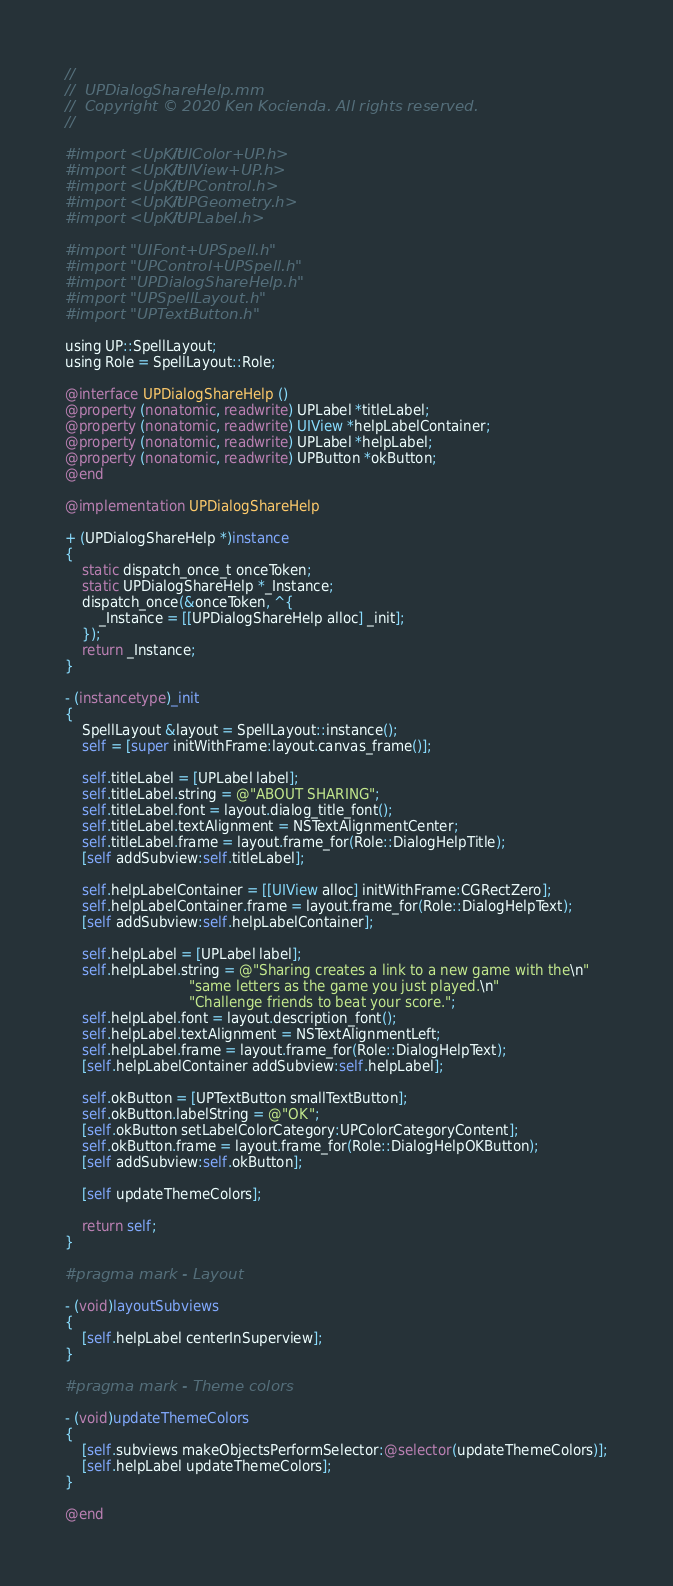<code> <loc_0><loc_0><loc_500><loc_500><_ObjectiveC_>//
//  UPDialogShareHelp.mm
//  Copyright © 2020 Ken Kocienda. All rights reserved.
//

#import <UpKit/UIColor+UP.h>
#import <UpKit/UIView+UP.h>
#import <UpKit/UPControl.h>
#import <UpKit/UPGeometry.h>
#import <UpKit/UPLabel.h>

#import "UIFont+UPSpell.h"
#import "UPControl+UPSpell.h"
#import "UPDialogShareHelp.h"
#import "UPSpellLayout.h"
#import "UPTextButton.h"

using UP::SpellLayout;
using Role = SpellLayout::Role;

@interface UPDialogShareHelp ()
@property (nonatomic, readwrite) UPLabel *titleLabel;
@property (nonatomic, readwrite) UIView *helpLabelContainer;
@property (nonatomic, readwrite) UPLabel *helpLabel;
@property (nonatomic, readwrite) UPButton *okButton;
@end

@implementation UPDialogShareHelp

+ (UPDialogShareHelp *)instance
{
    static dispatch_once_t onceToken;
    static UPDialogShareHelp *_Instance;
    dispatch_once(&onceToken, ^{
        _Instance = [[UPDialogShareHelp alloc] _init];
    });
    return _Instance;
}

- (instancetype)_init
{
    SpellLayout &layout = SpellLayout::instance();
    self = [super initWithFrame:layout.canvas_frame()];

    self.titleLabel = [UPLabel label];
    self.titleLabel.string = @"ABOUT SHARING";
    self.titleLabel.font = layout.dialog_title_font();
    self.titleLabel.textAlignment = NSTextAlignmentCenter;
    self.titleLabel.frame = layout.frame_for(Role::DialogHelpTitle);
    [self addSubview:self.titleLabel];

    self.helpLabelContainer = [[UIView alloc] initWithFrame:CGRectZero];
    self.helpLabelContainer.frame = layout.frame_for(Role::DialogHelpText);
    [self addSubview:self.helpLabelContainer];

    self.helpLabel = [UPLabel label];
    self.helpLabel.string = @"Sharing creates a link to a new game with the\n"
                             "same letters as the game you just played.\n"
                             "Challenge friends to beat your score.";
    self.helpLabel.font = layout.description_font();
    self.helpLabel.textAlignment = NSTextAlignmentLeft;
    self.helpLabel.frame = layout.frame_for(Role::DialogHelpText);
    [self.helpLabelContainer addSubview:self.helpLabel];

    self.okButton = [UPTextButton smallTextButton];
    self.okButton.labelString = @"OK";
    [self.okButton setLabelColorCategory:UPColorCategoryContent];
    self.okButton.frame = layout.frame_for(Role::DialogHelpOKButton);
    [self addSubview:self.okButton];

    [self updateThemeColors];

    return self;
}

#pragma mark - Layout

- (void)layoutSubviews
{
    [self.helpLabel centerInSuperview];
}

#pragma mark - Theme colors

- (void)updateThemeColors
{
    [self.subviews makeObjectsPerformSelector:@selector(updateThemeColors)];
    [self.helpLabel updateThemeColors];
}

@end
</code> 